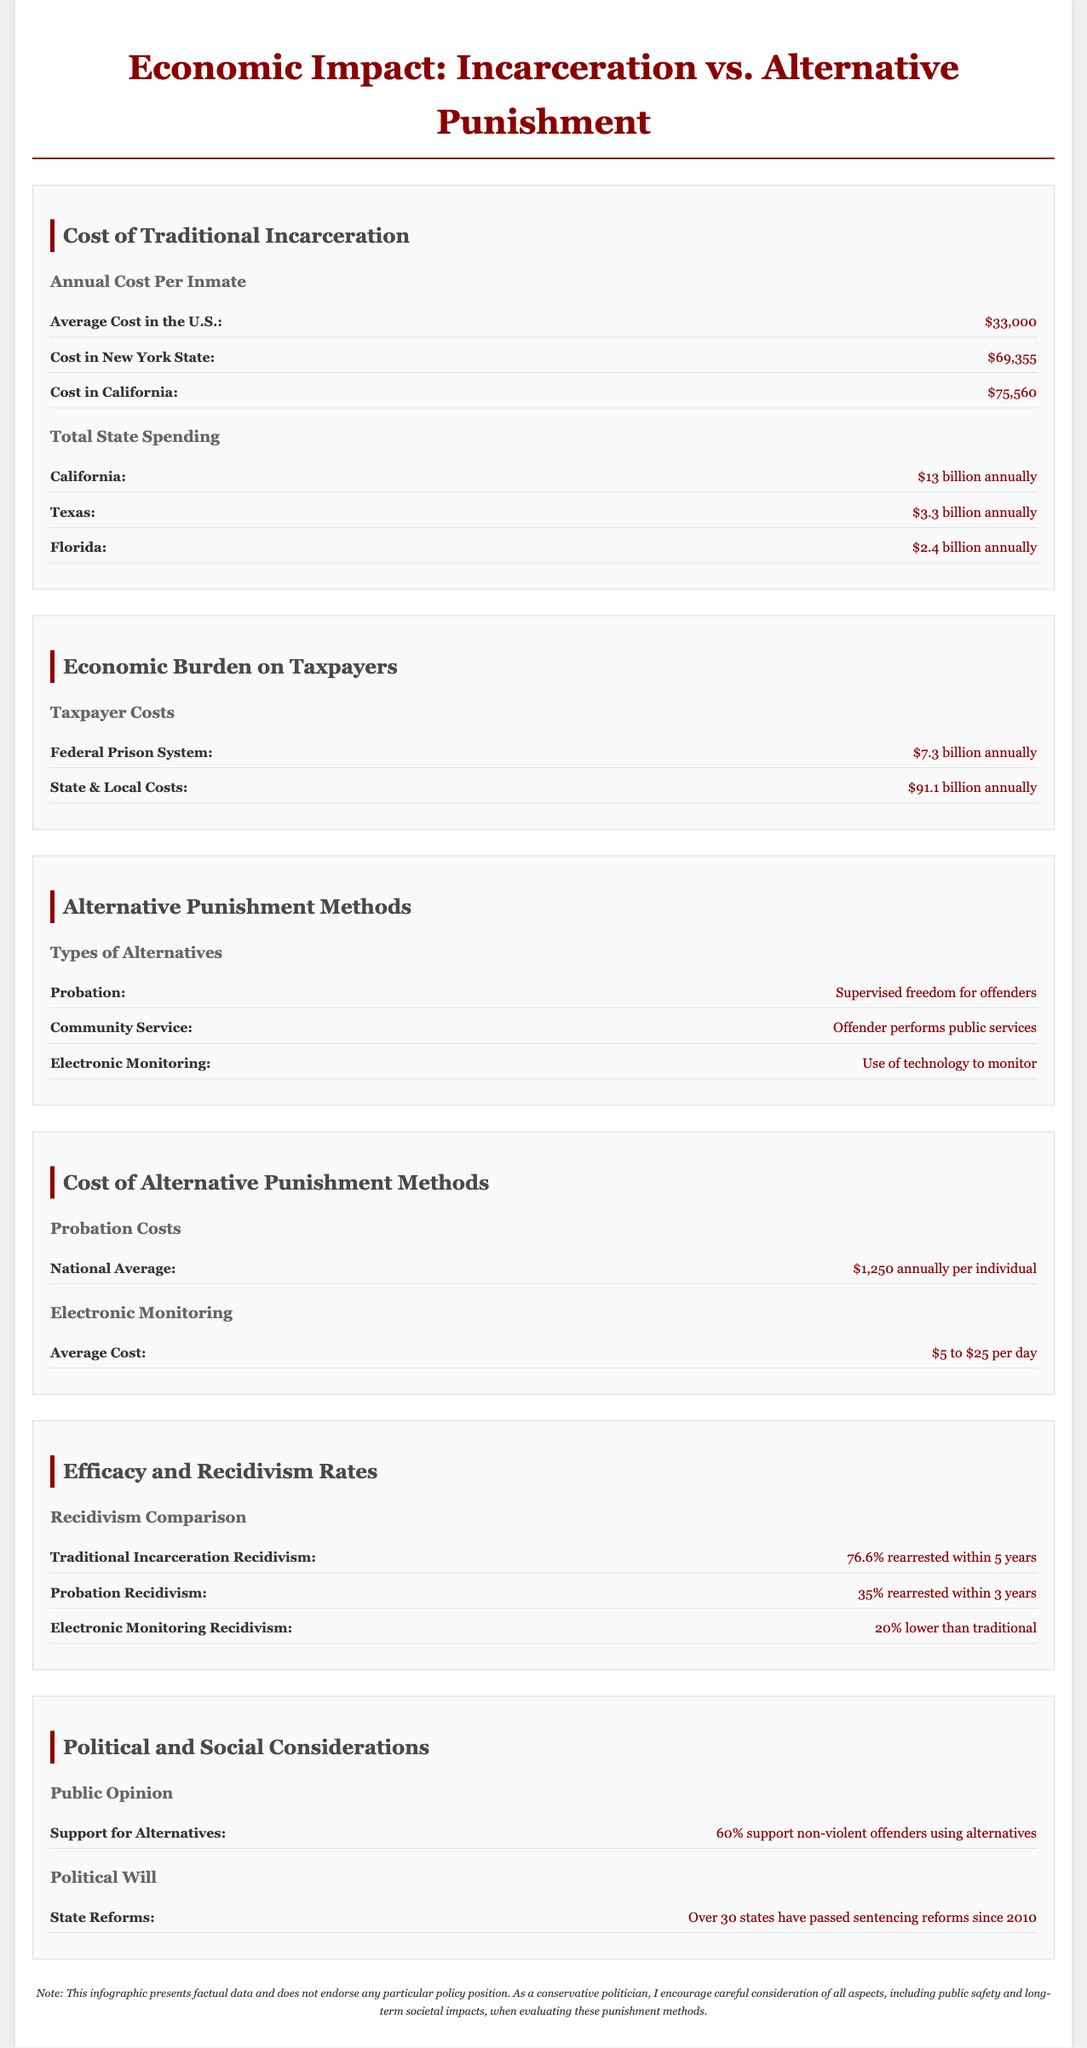what is the average cost of traditional incarceration in the U.S.? The average cost of traditional incarceration in the U.S. is stated directly in the document as $33,000.
Answer: $33,000 what is the cost of incarceration in California? The document specifies the cost of incarceration in California as $75,560.
Answer: $75,560 what is the annual cost of federal prison system? The annual cost of the federal prison system is mentioned in the infographic as $7.3 billion.
Answer: $7.3 billion what is the average cost of probation? The average cost of probation is listed as $1,250 annually per individual.
Answer: $1,250 what percentage of traditional incarceration leads to recidivism within 5 years? The document indicates that 76.6% of those incarcerated traditionally are rearrested within 5 years.
Answer: 76.6% how much lower is electronic monitoring recidivism compared to traditional methods? The infographic states that electronic monitoring recidivism is 20% lower than traditional methods.
Answer: 20% how many states have passed sentencing reforms since 2010? The document claims that over 30 states have passed sentencing reforms since 2010.
Answer: Over 30 states what is the public support percentage for alternatives for non-violent offenders? According to the document, 60% support non-violent offenders using alternatives.
Answer: 60% what is the total state spending for California's incarceration? The total state spending for California's incarceration is documented as $13 billion annually.
Answer: $13 billion annually what is the average cost of electronic monitoring? The average cost of electronic monitoring is noted as $5 to $25 per day.
Answer: $5 to $25 per day 